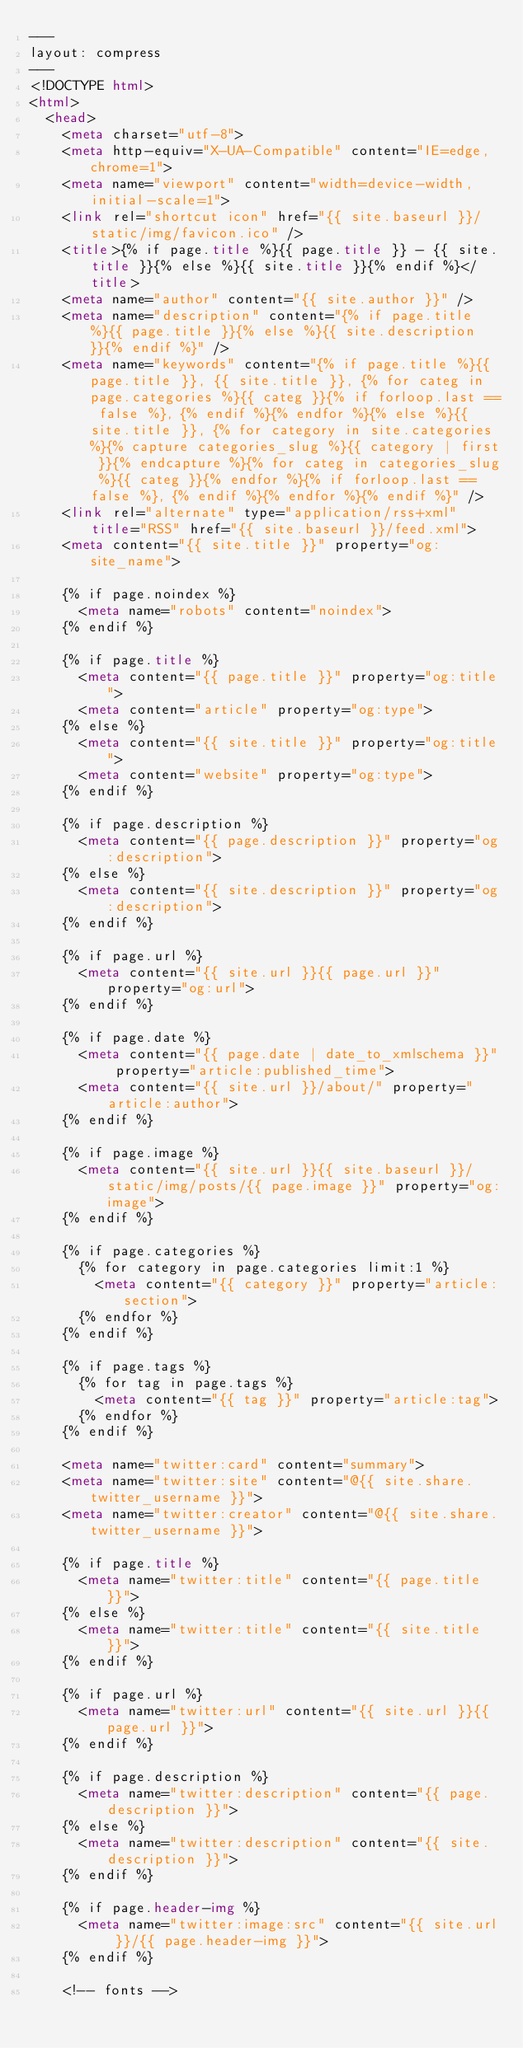<code> <loc_0><loc_0><loc_500><loc_500><_HTML_>---
layout: compress
---
<!DOCTYPE html>
<html>
  <head>
    <meta charset="utf-8">
    <meta http-equiv="X-UA-Compatible" content="IE=edge,chrome=1">
    <meta name="viewport" content="width=device-width, initial-scale=1">
    <link rel="shortcut icon" href="{{ site.baseurl }}/static/img/favicon.ico" />
    <title>{% if page.title %}{{ page.title }} - {{ site.title }}{% else %}{{ site.title }}{% endif %}</title>
    <meta name="author" content="{{ site.author }}" />
    <meta name="description" content="{% if page.title %}{{ page.title }}{% else %}{{ site.description }}{% endif %}" />
    <meta name="keywords" content="{% if page.title %}{{ page.title }}, {{ site.title }}, {% for categ in page.categories %}{{ categ }}{% if forloop.last == false %}, {% endif %}{% endfor %}{% else %}{{ site.title }}, {% for category in site.categories %}{% capture categories_slug %}{{ category | first }}{% endcapture %}{% for categ in categories_slug %}{{ categ }}{% endfor %}{% if forloop.last == false %}, {% endif %}{% endfor %}{% endif %}" />
    <link rel="alternate" type="application/rss+xml" title="RSS" href="{{ site.baseurl }}/feed.xml">
    <meta content="{{ site.title }}" property="og:site_name">

    {% if page.noindex %}
      <meta name="robots" content="noindex">
    {% endif %}

    {% if page.title %}
      <meta content="{{ page.title }}" property="og:title">
      <meta content="article" property="og:type">
    {% else %}
      <meta content="{{ site.title }}" property="og:title">
      <meta content="website" property="og:type">
    {% endif %}

    {% if page.description %}
      <meta content="{{ page.description }}" property="og:description">
    {% else %}
      <meta content="{{ site.description }}" property="og:description">
    {% endif %}

    {% if page.url %}
      <meta content="{{ site.url }}{{ page.url }}" property="og:url">
    {% endif %}

    {% if page.date %}
      <meta content="{{ page.date | date_to_xmlschema }}" property="article:published_time">
      <meta content="{{ site.url }}/about/" property="article:author">
    {% endif %}

    {% if page.image %}
      <meta content="{{ site.url }}{{ site.baseurl }}/static/img/posts/{{ page.image }}" property="og:image">
    {% endif %}

    {% if page.categories %}
      {% for category in page.categories limit:1 %}
        <meta content="{{ category }}" property="article:section">
      {% endfor %}
    {% endif %}

    {% if page.tags %}
      {% for tag in page.tags %}
        <meta content="{{ tag }}" property="article:tag">
      {% endfor %}
    {% endif %}

    <meta name="twitter:card" content="summary">
    <meta name="twitter:site" content="@{{ site.share.twitter_username }}">
    <meta name="twitter:creator" content="@{{ site.share.twitter_username }}">

    {% if page.title %}
      <meta name="twitter:title" content="{{ page.title }}">
    {% else %}
      <meta name="twitter:title" content="{{ site.title }}">
    {% endif %}

    {% if page.url %}
      <meta name="twitter:url" content="{{ site.url }}{{ page.url }}">
    {% endif %}

    {% if page.description %}
      <meta name="twitter:description" content="{{ page.description }}">
    {% else %}
      <meta name="twitter:description" content="{{ site.description }}">
    {% endif %}

    {% if page.header-img %}
      <meta name="twitter:image:src" content="{{ site.url }}/{{ page.header-img }}">
    {% endif %}

    <!-- fonts --></code> 